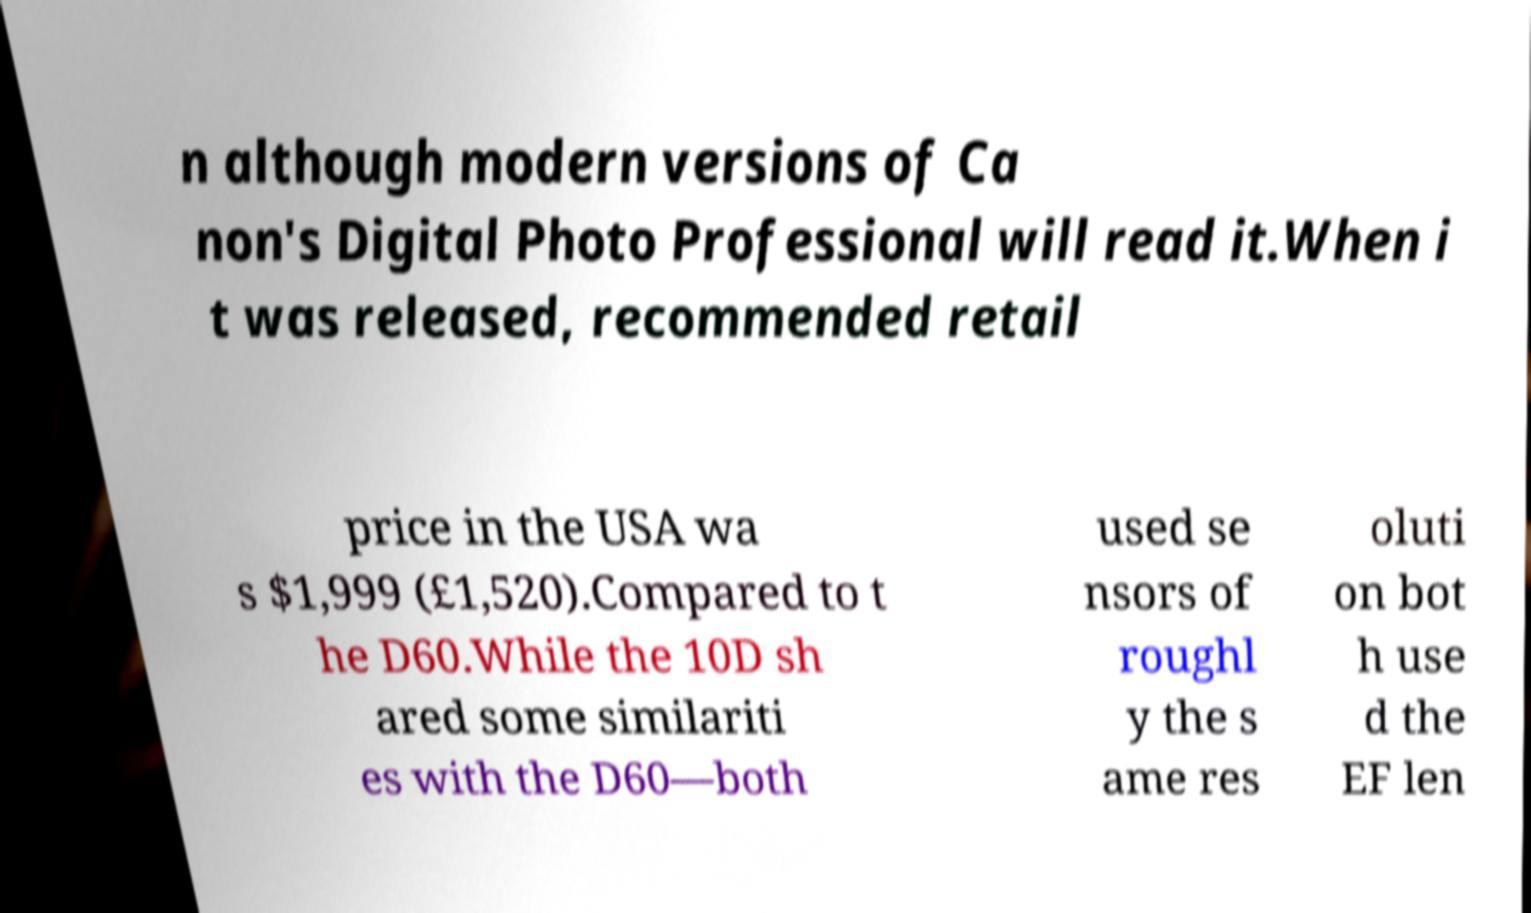Could you assist in decoding the text presented in this image and type it out clearly? n although modern versions of Ca non's Digital Photo Professional will read it.When i t was released, recommended retail price in the USA wa s $1,999 (£1,520).Compared to t he D60.While the 10D sh ared some similariti es with the D60—both used se nsors of roughl y the s ame res oluti on bot h use d the EF len 